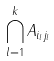<formula> <loc_0><loc_0><loc_500><loc_500>\bigcap _ { l = 1 } ^ { k } A _ { i _ { l } j _ { l } }</formula> 